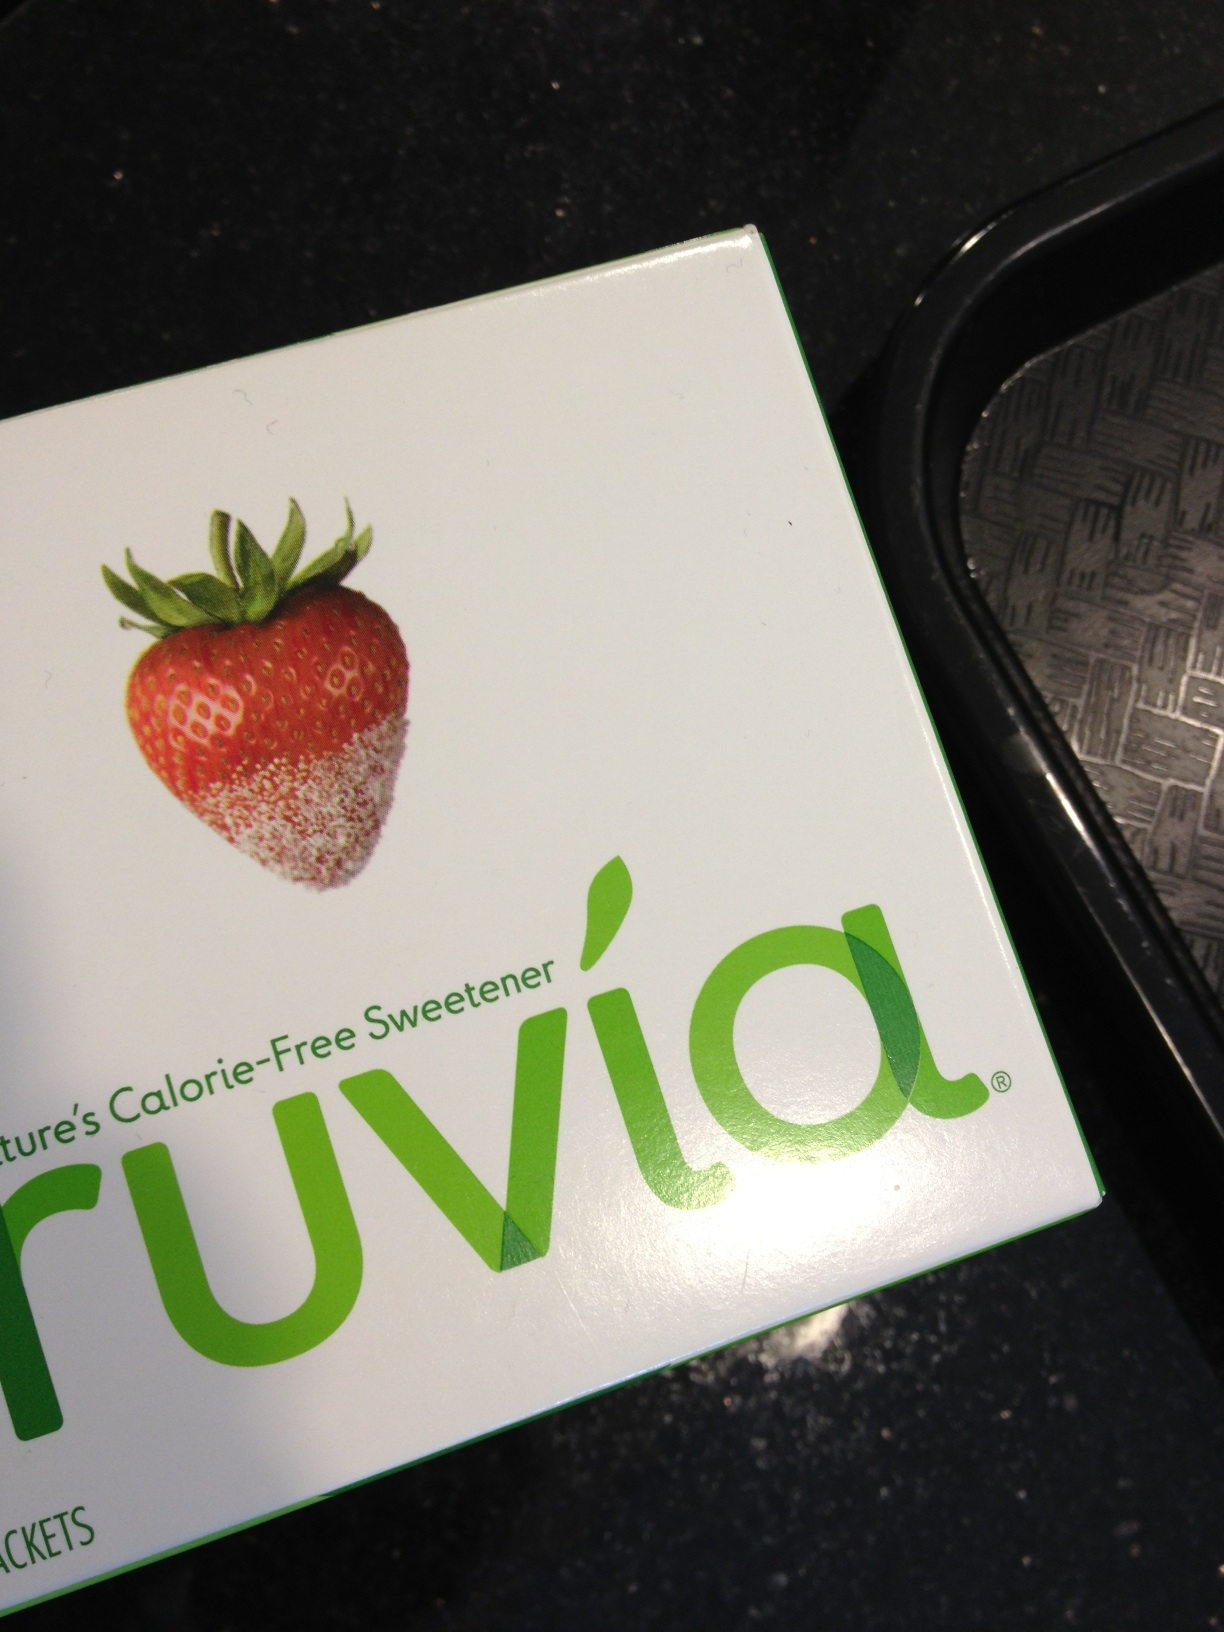How does the sweetness of Truvia compare to regular sugar? Truvia is significantly sweeter than regular sugar. A small amount of Truvia provides a level of sweetness comparable to that of a larger amount of sugar, allowing users to achieve their desired sweetness while consuming fewer calories. 